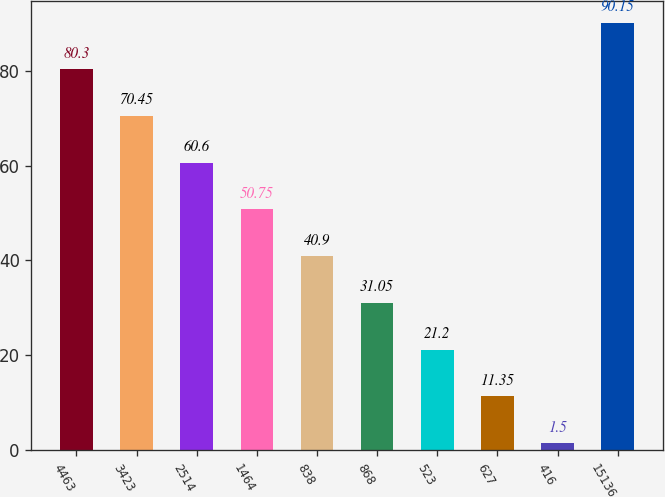Convert chart. <chart><loc_0><loc_0><loc_500><loc_500><bar_chart><fcel>4463<fcel>3423<fcel>2514<fcel>1464<fcel>838<fcel>868<fcel>523<fcel>627<fcel>416<fcel>15136<nl><fcel>80.3<fcel>70.45<fcel>60.6<fcel>50.75<fcel>40.9<fcel>31.05<fcel>21.2<fcel>11.35<fcel>1.5<fcel>90.15<nl></chart> 